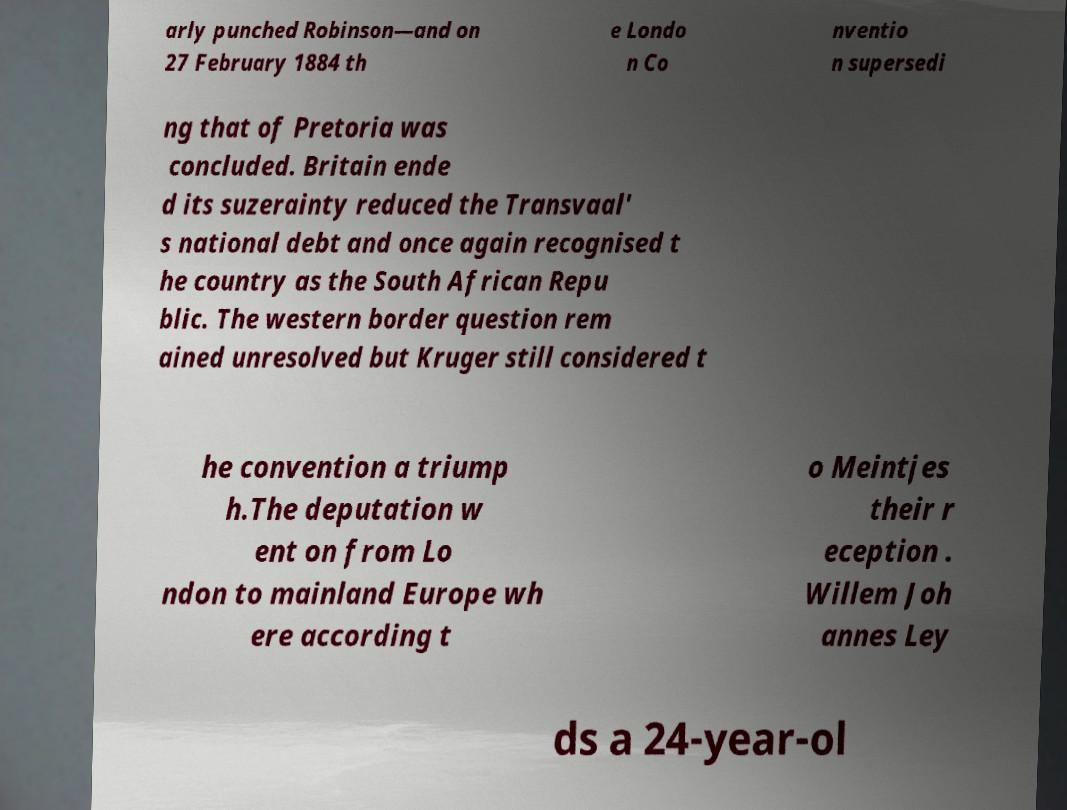Can you accurately transcribe the text from the provided image for me? arly punched Robinson—and on 27 February 1884 th e Londo n Co nventio n supersedi ng that of Pretoria was concluded. Britain ende d its suzerainty reduced the Transvaal' s national debt and once again recognised t he country as the South African Repu blic. The western border question rem ained unresolved but Kruger still considered t he convention a triump h.The deputation w ent on from Lo ndon to mainland Europe wh ere according t o Meintjes their r eception . Willem Joh annes Ley ds a 24-year-ol 